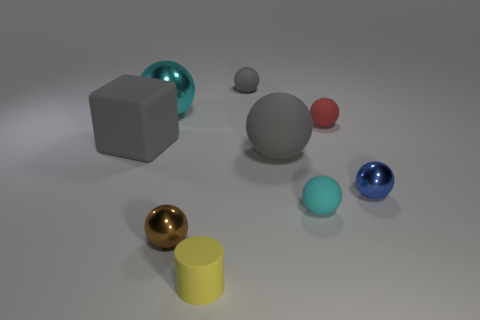What shape is the metallic object that is in front of the cyan object that is in front of the small metal object that is behind the small cyan matte sphere?
Offer a terse response. Sphere. Are there the same number of small shiny balls that are behind the gray matte block and small blue metal balls?
Your answer should be compact. No. Does the yellow rubber cylinder have the same size as the red matte ball?
Your response must be concise. Yes. How many matte things are cylinders or brown spheres?
Your answer should be very brief. 1. There is a gray sphere that is the same size as the matte cylinder; what is it made of?
Provide a succinct answer. Rubber. How many other objects are there of the same material as the small red thing?
Offer a terse response. 5. Is the number of tiny cyan rubber things in front of the small cylinder less than the number of brown cubes?
Keep it short and to the point. No. Do the small cyan object and the big cyan object have the same shape?
Provide a succinct answer. Yes. There is a brown shiny sphere on the right side of the metal sphere that is behind the blue object that is in front of the small gray matte object; what size is it?
Your answer should be compact. Small. What is the material of the blue thing that is the same shape as the small cyan matte thing?
Offer a very short reply. Metal. 